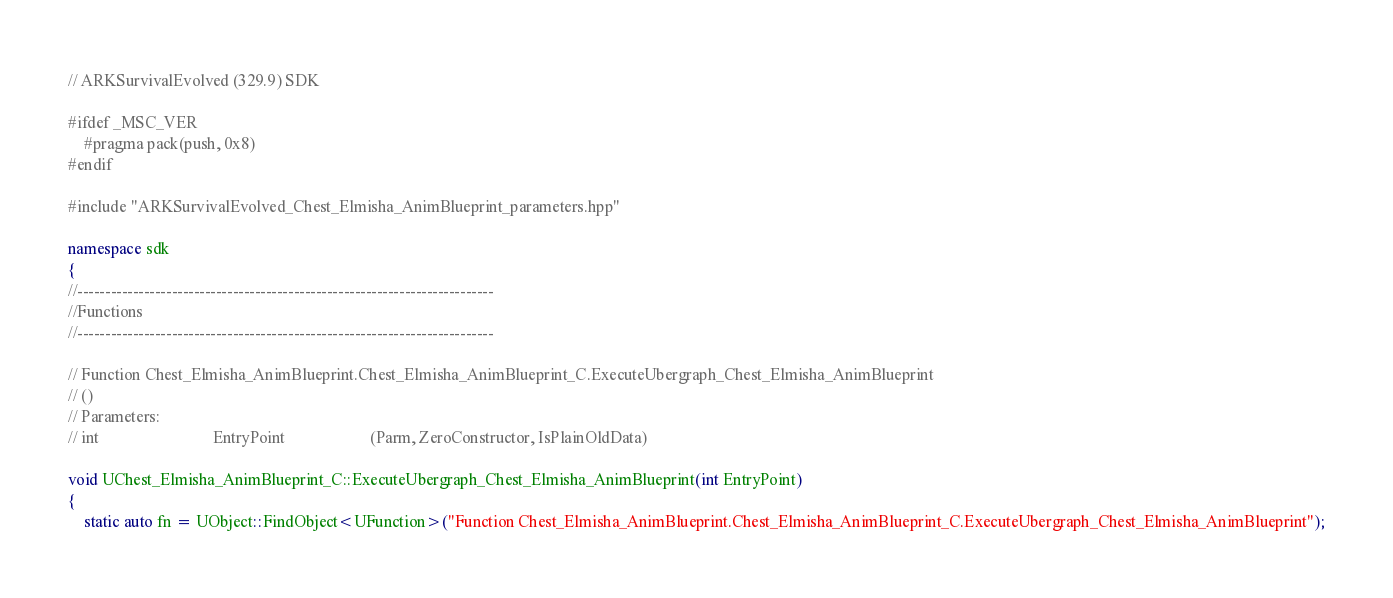<code> <loc_0><loc_0><loc_500><loc_500><_C++_>// ARKSurvivalEvolved (329.9) SDK

#ifdef _MSC_VER
	#pragma pack(push, 0x8)
#endif

#include "ARKSurvivalEvolved_Chest_Elmisha_AnimBlueprint_parameters.hpp"

namespace sdk
{
//---------------------------------------------------------------------------
//Functions
//---------------------------------------------------------------------------

// Function Chest_Elmisha_AnimBlueprint.Chest_Elmisha_AnimBlueprint_C.ExecuteUbergraph_Chest_Elmisha_AnimBlueprint
// ()
// Parameters:
// int                            EntryPoint                     (Parm, ZeroConstructor, IsPlainOldData)

void UChest_Elmisha_AnimBlueprint_C::ExecuteUbergraph_Chest_Elmisha_AnimBlueprint(int EntryPoint)
{
	static auto fn = UObject::FindObject<UFunction>("Function Chest_Elmisha_AnimBlueprint.Chest_Elmisha_AnimBlueprint_C.ExecuteUbergraph_Chest_Elmisha_AnimBlueprint");
</code> 